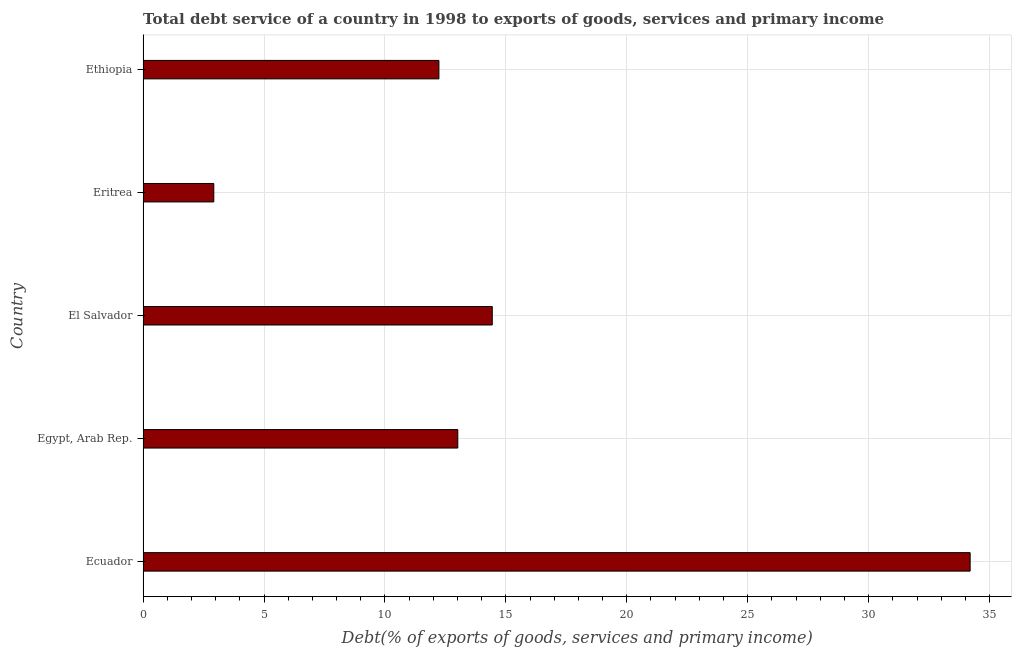Does the graph contain any zero values?
Your response must be concise. No. Does the graph contain grids?
Ensure brevity in your answer.  Yes. What is the title of the graph?
Give a very brief answer. Total debt service of a country in 1998 to exports of goods, services and primary income. What is the label or title of the X-axis?
Make the answer very short. Debt(% of exports of goods, services and primary income). What is the total debt service in Ethiopia?
Your answer should be very brief. 12.23. Across all countries, what is the maximum total debt service?
Give a very brief answer. 34.2. Across all countries, what is the minimum total debt service?
Offer a terse response. 2.92. In which country was the total debt service maximum?
Your answer should be compact. Ecuador. In which country was the total debt service minimum?
Provide a short and direct response. Eritrea. What is the sum of the total debt service?
Offer a terse response. 76.8. What is the difference between the total debt service in Eritrea and Ethiopia?
Give a very brief answer. -9.31. What is the average total debt service per country?
Make the answer very short. 15.36. What is the median total debt service?
Your answer should be compact. 13.01. In how many countries, is the total debt service greater than 19 %?
Keep it short and to the point. 1. What is the ratio of the total debt service in Ecuador to that in Egypt, Arab Rep.?
Provide a short and direct response. 2.63. Is the total debt service in El Salvador less than that in Eritrea?
Your answer should be compact. No. What is the difference between the highest and the second highest total debt service?
Provide a short and direct response. 19.76. What is the difference between the highest and the lowest total debt service?
Provide a short and direct response. 31.27. In how many countries, is the total debt service greater than the average total debt service taken over all countries?
Give a very brief answer. 1. Are all the bars in the graph horizontal?
Provide a succinct answer. Yes. How many countries are there in the graph?
Offer a terse response. 5. What is the difference between two consecutive major ticks on the X-axis?
Keep it short and to the point. 5. What is the Debt(% of exports of goods, services and primary income) in Ecuador?
Your answer should be very brief. 34.2. What is the Debt(% of exports of goods, services and primary income) in Egypt, Arab Rep.?
Give a very brief answer. 13.01. What is the Debt(% of exports of goods, services and primary income) of El Salvador?
Make the answer very short. 14.44. What is the Debt(% of exports of goods, services and primary income) in Eritrea?
Ensure brevity in your answer.  2.92. What is the Debt(% of exports of goods, services and primary income) of Ethiopia?
Offer a very short reply. 12.23. What is the difference between the Debt(% of exports of goods, services and primary income) in Ecuador and Egypt, Arab Rep.?
Your response must be concise. 21.18. What is the difference between the Debt(% of exports of goods, services and primary income) in Ecuador and El Salvador?
Offer a terse response. 19.76. What is the difference between the Debt(% of exports of goods, services and primary income) in Ecuador and Eritrea?
Your answer should be very brief. 31.27. What is the difference between the Debt(% of exports of goods, services and primary income) in Ecuador and Ethiopia?
Provide a succinct answer. 21.96. What is the difference between the Debt(% of exports of goods, services and primary income) in Egypt, Arab Rep. and El Salvador?
Offer a very short reply. -1.43. What is the difference between the Debt(% of exports of goods, services and primary income) in Egypt, Arab Rep. and Eritrea?
Provide a short and direct response. 10.09. What is the difference between the Debt(% of exports of goods, services and primary income) in Egypt, Arab Rep. and Ethiopia?
Offer a very short reply. 0.78. What is the difference between the Debt(% of exports of goods, services and primary income) in El Salvador and Eritrea?
Offer a very short reply. 11.51. What is the difference between the Debt(% of exports of goods, services and primary income) in El Salvador and Ethiopia?
Provide a short and direct response. 2.21. What is the difference between the Debt(% of exports of goods, services and primary income) in Eritrea and Ethiopia?
Offer a terse response. -9.31. What is the ratio of the Debt(% of exports of goods, services and primary income) in Ecuador to that in Egypt, Arab Rep.?
Ensure brevity in your answer.  2.63. What is the ratio of the Debt(% of exports of goods, services and primary income) in Ecuador to that in El Salvador?
Ensure brevity in your answer.  2.37. What is the ratio of the Debt(% of exports of goods, services and primary income) in Ecuador to that in Eritrea?
Make the answer very short. 11.69. What is the ratio of the Debt(% of exports of goods, services and primary income) in Ecuador to that in Ethiopia?
Offer a terse response. 2.8. What is the ratio of the Debt(% of exports of goods, services and primary income) in Egypt, Arab Rep. to that in El Salvador?
Your answer should be compact. 0.9. What is the ratio of the Debt(% of exports of goods, services and primary income) in Egypt, Arab Rep. to that in Eritrea?
Keep it short and to the point. 4.45. What is the ratio of the Debt(% of exports of goods, services and primary income) in Egypt, Arab Rep. to that in Ethiopia?
Provide a short and direct response. 1.06. What is the ratio of the Debt(% of exports of goods, services and primary income) in El Salvador to that in Eritrea?
Your response must be concise. 4.94. What is the ratio of the Debt(% of exports of goods, services and primary income) in El Salvador to that in Ethiopia?
Your answer should be compact. 1.18. What is the ratio of the Debt(% of exports of goods, services and primary income) in Eritrea to that in Ethiopia?
Your answer should be very brief. 0.24. 